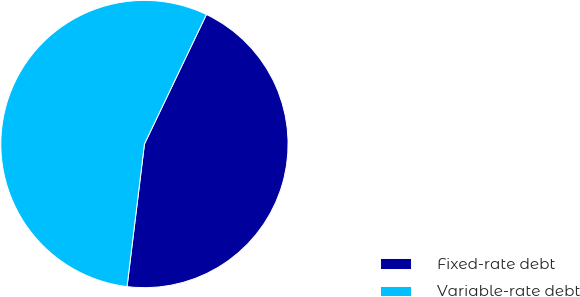Convert chart to OTSL. <chart><loc_0><loc_0><loc_500><loc_500><pie_chart><fcel>Fixed-rate debt<fcel>Variable-rate debt<nl><fcel>44.83%<fcel>55.17%<nl></chart> 